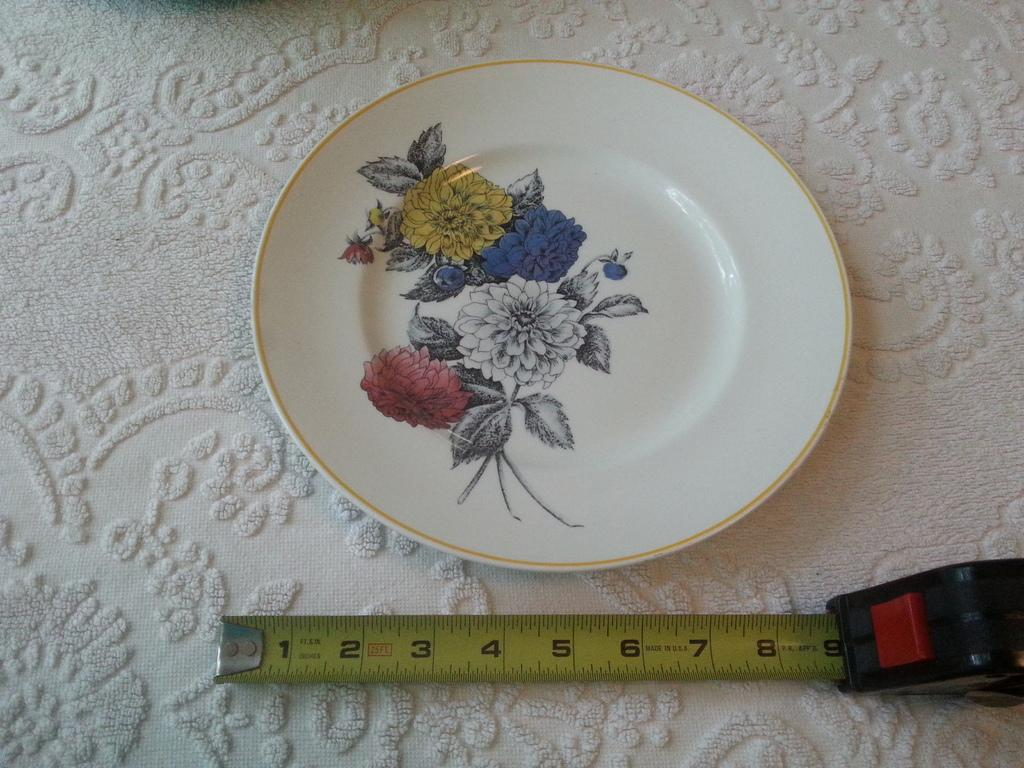What is on the table in the image? There is a plate on a table in the image. What design is on the plate? The plate has a print of flowers. What tool is visible in the image? There is a measuring tape in the image. What covers the table in the image? There is a tablecloth on the table in the image. How many people are in the crowd gathered around the table in the image? There is no crowd present in the image; it only shows a plate, a measuring tape, and a tablecloth on the table. 